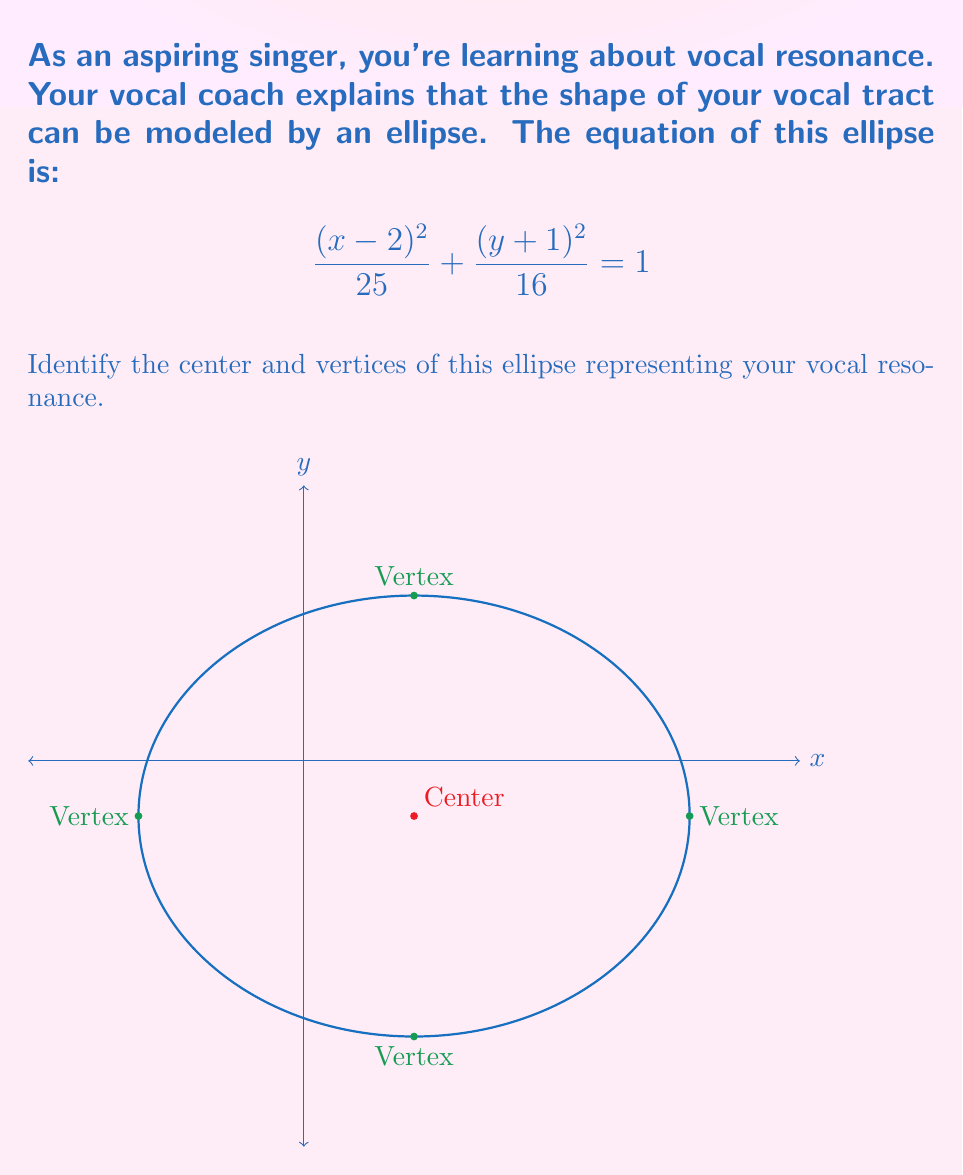Show me your answer to this math problem. Let's approach this step-by-step:

1) The general form of an ellipse equation is:

   $$\frac{(x-h)^2}{a^2} + \frac{(y-k)^2}{b^2} = 1$$

   where $(h,k)$ is the center, and $a$ and $b$ are the lengths of the semi-major and semi-minor axes.

2) Comparing our equation to the general form:

   $$\frac{(x-2)^2}{25} + \frac{(y+1)^2}{16} = 1$$

3) We can identify:
   - $h = 2$
   - $k = -1$
   - $a^2 = 25$, so $a = 5$
   - $b^2 = 16$, so $b = 4$

4) Therefore, the center of the ellipse is $(2,-1)$.

5) The vertices of an ellipse are located $a$ units away from the center along the major axis. In this case, the major axis is horizontal because $a > b$.

6) The x-coordinates of the vertices are:
   - $2 + 5 = 7$ (right vertex)
   - $2 - 5 = -3$ (left vertex)

7) The y-coordinate of these vertices is the same as the y-coordinate of the center, -1.

Therefore, the vertices are $(-3,-1)$ and $(7,-1)$.
Answer: Center: $(2,-1)$, Vertices: $(-3,-1)$ and $(7,-1)$ 